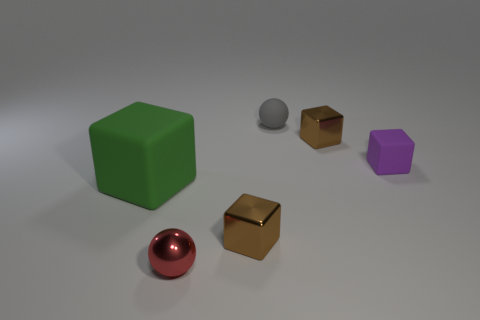Add 4 big matte cubes. How many objects exist? 10 Subtract all green rubber blocks. How many blocks are left? 3 Subtract 2 blocks. How many blocks are left? 2 Add 6 red things. How many red things exist? 7 Subtract all red balls. How many balls are left? 1 Subtract 0 cyan balls. How many objects are left? 6 Subtract all blocks. How many objects are left? 2 Subtract all purple blocks. Subtract all blue spheres. How many blocks are left? 3 Subtract all brown blocks. How many red balls are left? 1 Subtract all small purple shiny things. Subtract all big green cubes. How many objects are left? 5 